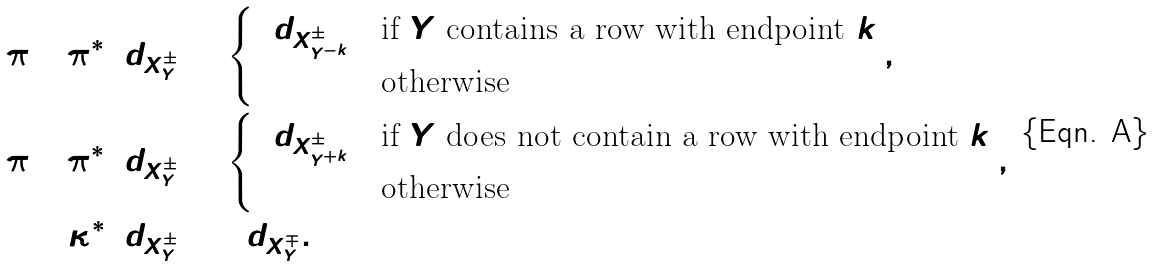Convert formula to latex. <formula><loc_0><loc_0><loc_500><loc_500>( \pi _ { 1 } ) _ { ! } \pi _ { 2 } ^ { * } \i d _ { X ^ { \pm } _ { Y } } & = \begin{cases} \i d _ { X ^ { \pm } _ { Y ^ { - k } } } & \text {if $Y$ contains a row with endpoint $k$} \\ 0 & \text {otherwise} \end{cases} , \\ ( \pi _ { 2 } ) _ { ! } \pi _ { 1 } ^ { * } \i d _ { X ^ { \pm } _ { Y } } & = \begin{cases} \i d _ { X ^ { \pm } _ { Y ^ { + k } } } & \text {if $Y$ does not contain a row with endpoint $k$} \\ 0 & \text {otherwise} \end{cases} , \\ \kappa ^ { * } \i d _ { X ^ { \pm } _ { Y } } & = \i d _ { X ^ { \mp } _ { Y } } .</formula> 